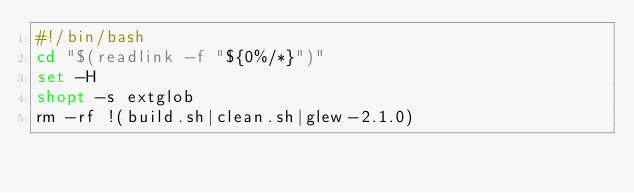<code> <loc_0><loc_0><loc_500><loc_500><_Bash_>#!/bin/bash
cd "$(readlink -f "${0%/*}")"
set -H
shopt -s extglob
rm -rf !(build.sh|clean.sh|glew-2.1.0)

</code> 